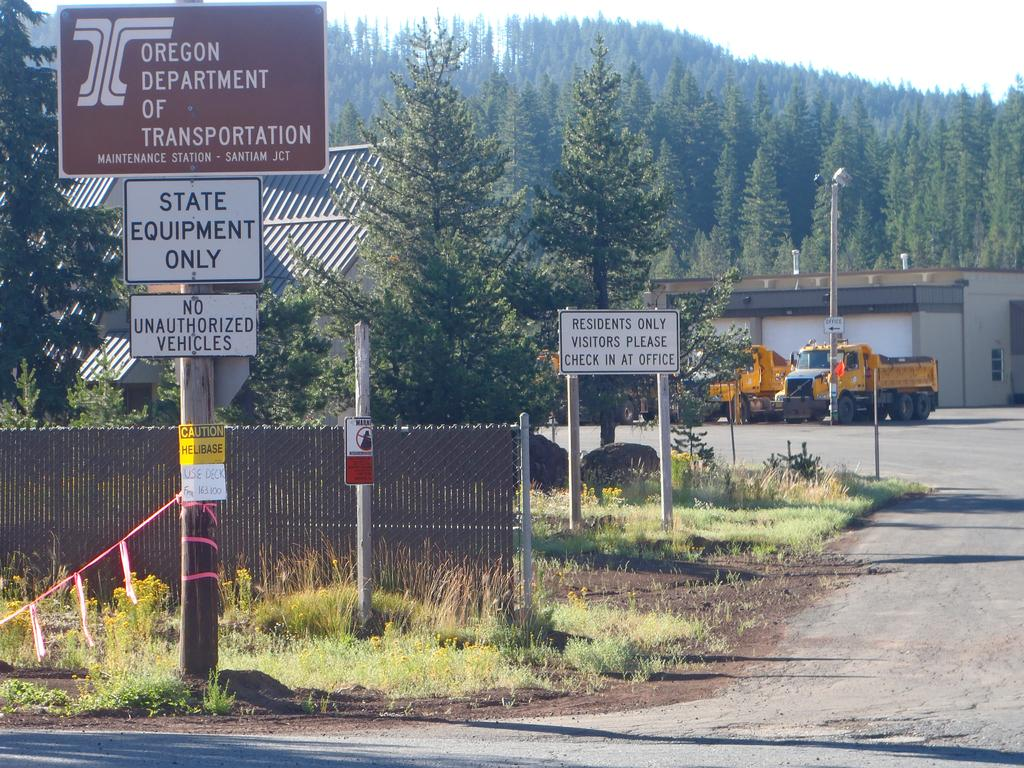What is on the poles in the image? There are boards on poles in the image. What type of terrain is visible in the image? There is grass visible in the image. What is happening on the road in the image? Vehicles are present on the road in the image. What type of vegetation can be seen in the image? There are plants and trees present in the image. What type of barrier is visible in the image? A fence is visible in the image. What type of structures are present in the image? There are houses in the image. What type of natural features are visible in the image? Rocks are visible in the image. What is visible in the background of the image? The sky is visible in the background of the image. What type of sticks are used to make the popcorn in the image? There is no popcorn or sticks present in the image. What do people believe about the boards on poles in the image? The image does not provide any information about people's beliefs regarding the boards on poles. 